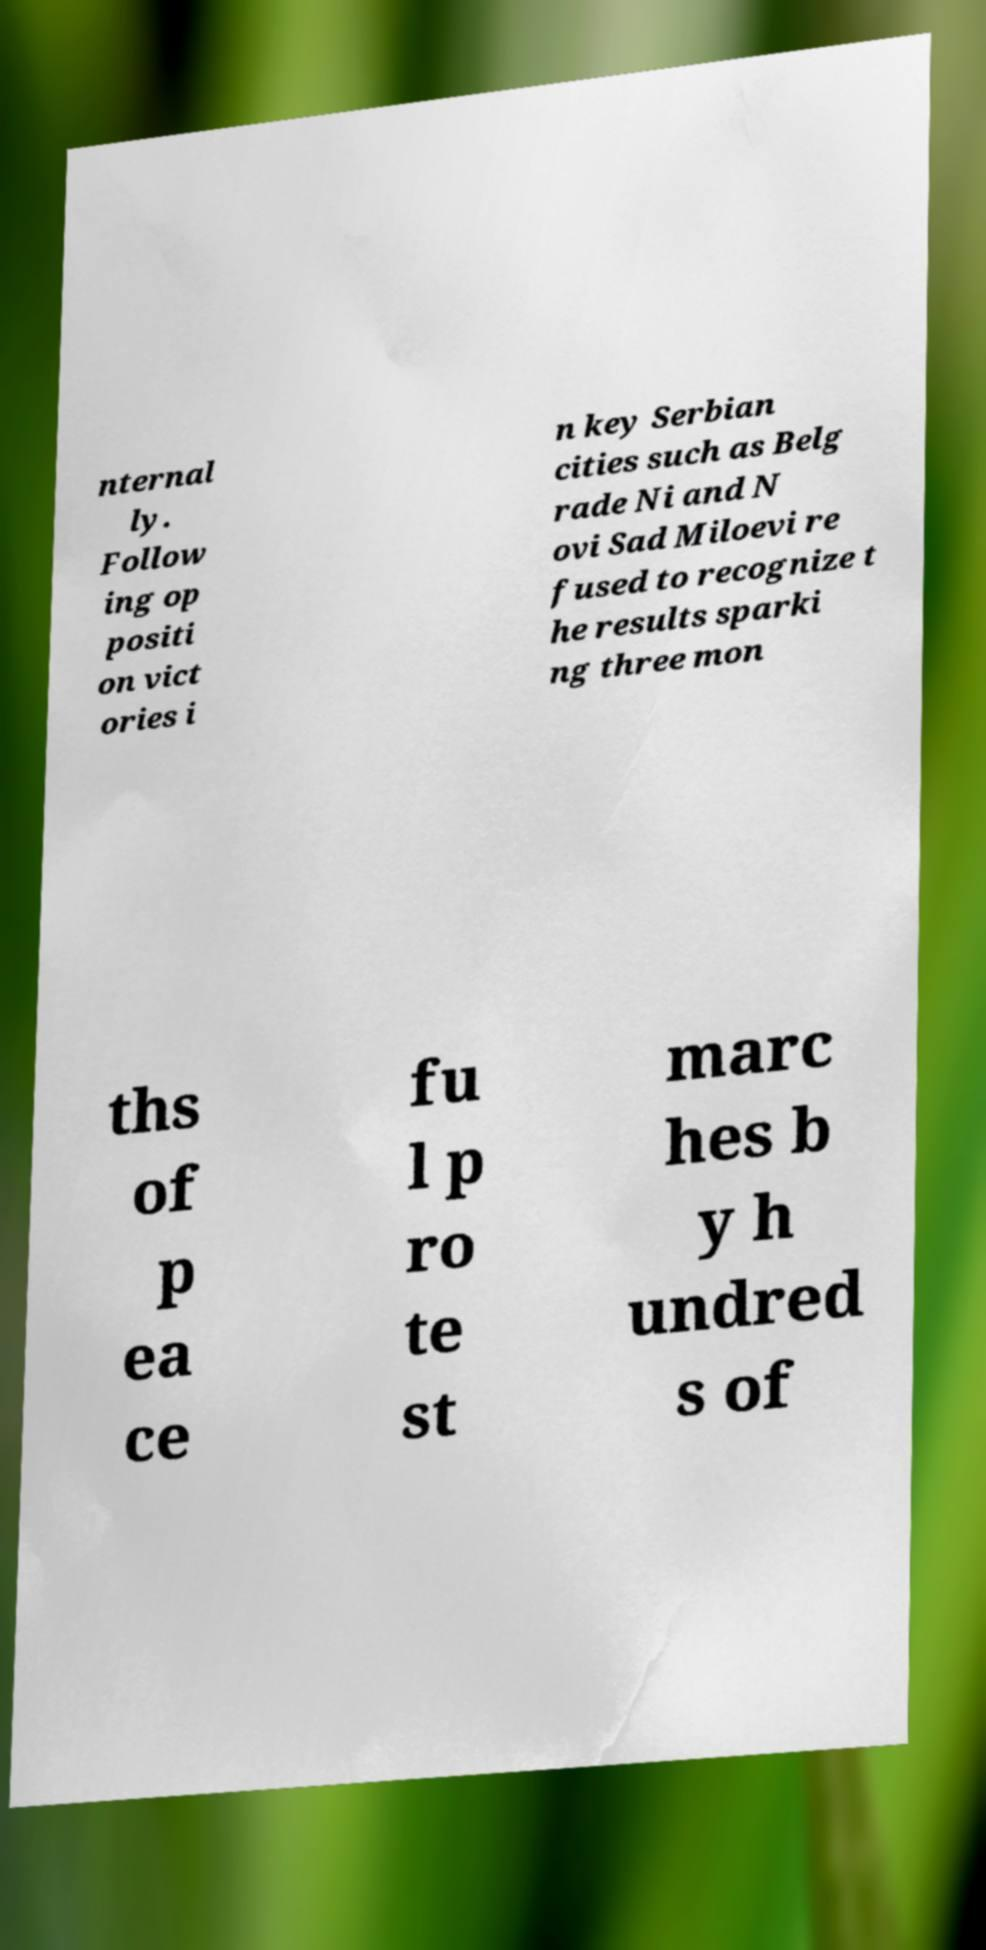Could you extract and type out the text from this image? nternal ly. Follow ing op positi on vict ories i n key Serbian cities such as Belg rade Ni and N ovi Sad Miloevi re fused to recognize t he results sparki ng three mon ths of p ea ce fu l p ro te st marc hes b y h undred s of 